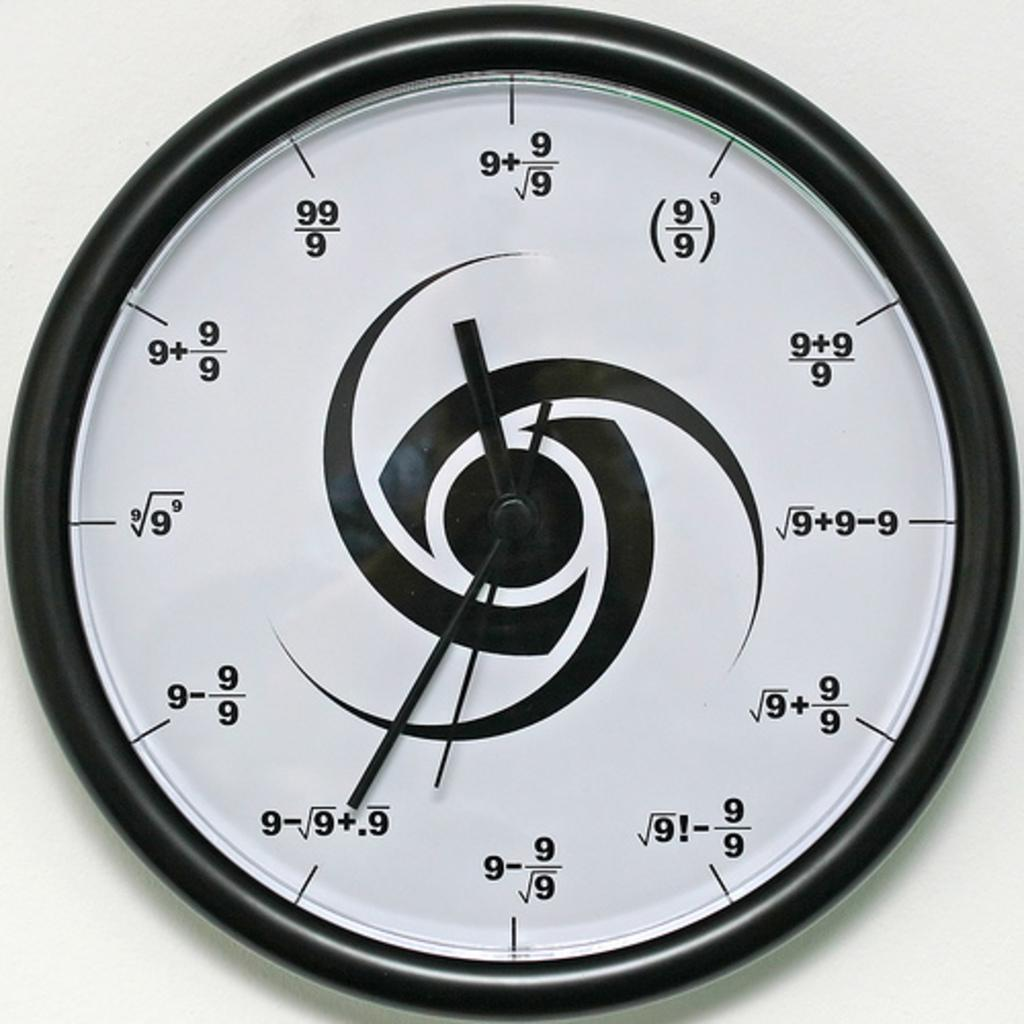<image>
Write a terse but informative summary of the picture. A clock displays numbers in various mathematical formulas using only the number 9 many times. 